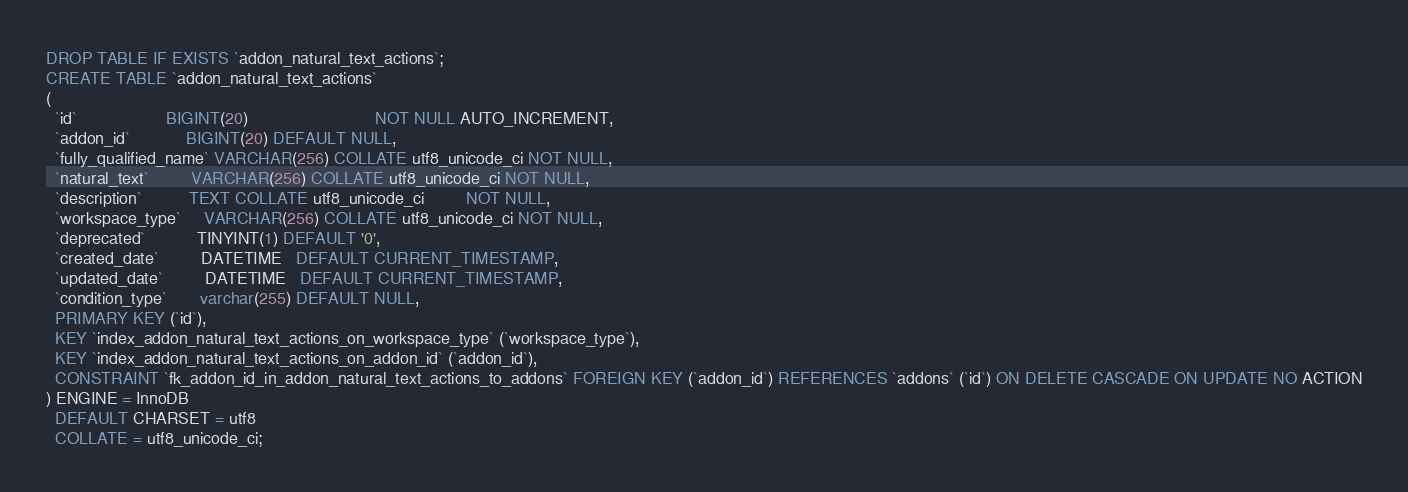Convert code to text. <code><loc_0><loc_0><loc_500><loc_500><_SQL_>DROP TABLE IF EXISTS `addon_natural_text_actions`;
CREATE TABLE `addon_natural_text_actions`
(
  `id`                   BIGINT(20)                           NOT NULL AUTO_INCREMENT,
  `addon_id`            BIGINT(20) DEFAULT NULL,
  `fully_qualified_name` VARCHAR(256) COLLATE utf8_unicode_ci NOT NULL,
  `natural_text`         VARCHAR(256) COLLATE utf8_unicode_ci NOT NULL,
  `description`          TEXT COLLATE utf8_unicode_ci         NOT NULL,
  `workspace_type`     VARCHAR(256) COLLATE utf8_unicode_ci NOT NULL,
  `deprecated`           TINYINT(1) DEFAULT '0',
  `created_date`         DATETIME   DEFAULT CURRENT_TIMESTAMP,
  `updated_date`         DATETIME   DEFAULT CURRENT_TIMESTAMP,
  `condition_type`       varchar(255) DEFAULT NULL,
  PRIMARY KEY (`id`),
  KEY `index_addon_natural_text_actions_on_workspace_type` (`workspace_type`),
  KEY `index_addon_natural_text_actions_on_addon_id` (`addon_id`),
  CONSTRAINT `fk_addon_id_in_addon_natural_text_actions_to_addons` FOREIGN KEY (`addon_id`) REFERENCES `addons` (`id`) ON DELETE CASCADE ON UPDATE NO ACTION
) ENGINE = InnoDB
  DEFAULT CHARSET = utf8
  COLLATE = utf8_unicode_ci;
</code> 